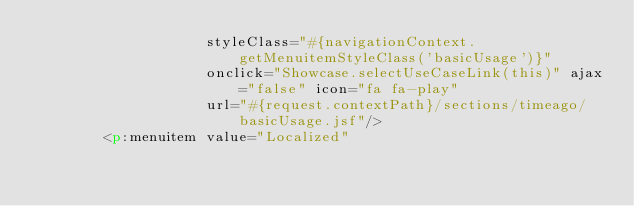<code> <loc_0><loc_0><loc_500><loc_500><_HTML_>                    styleClass="#{navigationContext.getMenuitemStyleClass('basicUsage')}"
                    onclick="Showcase.selectUseCaseLink(this)" ajax="false" icon="fa fa-play"
                    url="#{request.contextPath}/sections/timeago/basicUsage.jsf"/>
        <p:menuitem value="Localized"</code> 